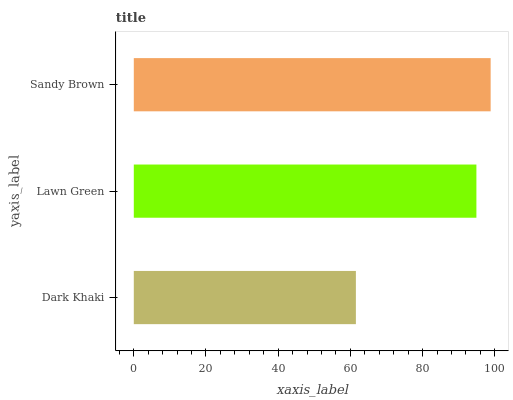Is Dark Khaki the minimum?
Answer yes or no. Yes. Is Sandy Brown the maximum?
Answer yes or no. Yes. Is Lawn Green the minimum?
Answer yes or no. No. Is Lawn Green the maximum?
Answer yes or no. No. Is Lawn Green greater than Dark Khaki?
Answer yes or no. Yes. Is Dark Khaki less than Lawn Green?
Answer yes or no. Yes. Is Dark Khaki greater than Lawn Green?
Answer yes or no. No. Is Lawn Green less than Dark Khaki?
Answer yes or no. No. Is Lawn Green the high median?
Answer yes or no. Yes. Is Lawn Green the low median?
Answer yes or no. Yes. Is Sandy Brown the high median?
Answer yes or no. No. Is Sandy Brown the low median?
Answer yes or no. No. 